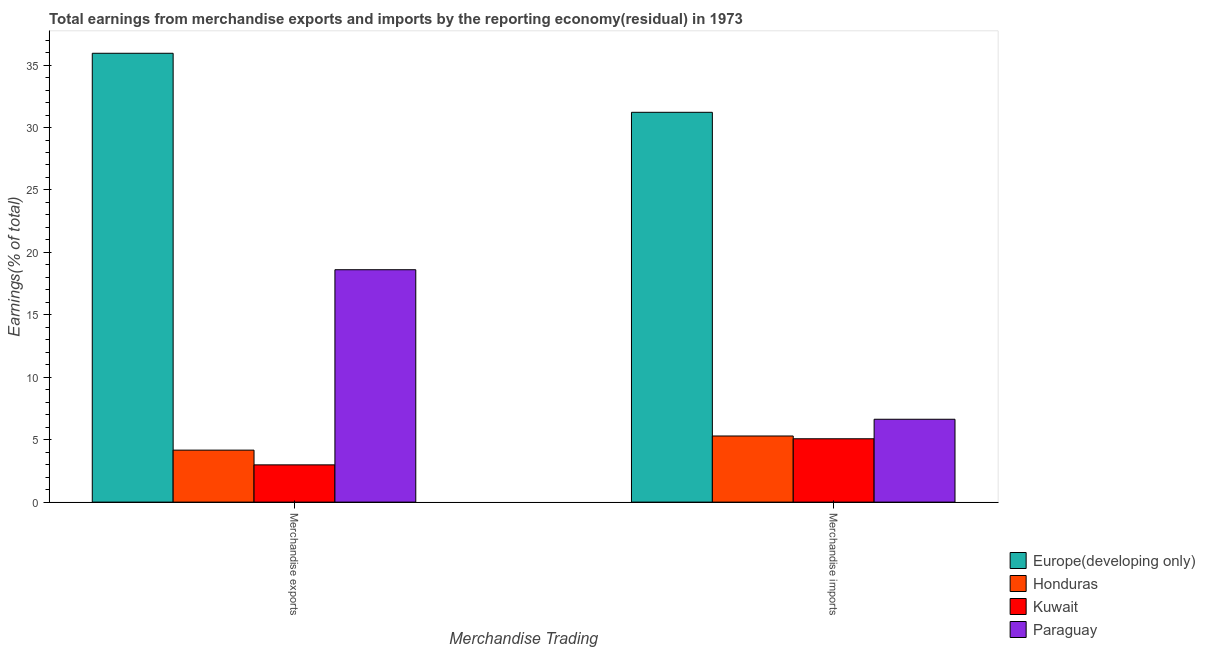Are the number of bars on each tick of the X-axis equal?
Offer a terse response. Yes. How many bars are there on the 2nd tick from the left?
Provide a short and direct response. 4. How many bars are there on the 1st tick from the right?
Your response must be concise. 4. What is the earnings from merchandise imports in Honduras?
Give a very brief answer. 5.3. Across all countries, what is the maximum earnings from merchandise imports?
Provide a short and direct response. 31.22. Across all countries, what is the minimum earnings from merchandise exports?
Make the answer very short. 2.98. In which country was the earnings from merchandise exports maximum?
Your answer should be compact. Europe(developing only). In which country was the earnings from merchandise imports minimum?
Your answer should be very brief. Kuwait. What is the total earnings from merchandise exports in the graph?
Your answer should be very brief. 61.71. What is the difference between the earnings from merchandise exports in Paraguay and that in Honduras?
Your response must be concise. 14.45. What is the difference between the earnings from merchandise exports in Paraguay and the earnings from merchandise imports in Honduras?
Your answer should be very brief. 13.32. What is the average earnings from merchandise exports per country?
Give a very brief answer. 15.43. What is the difference between the earnings from merchandise imports and earnings from merchandise exports in Europe(developing only)?
Offer a terse response. -4.73. What is the ratio of the earnings from merchandise imports in Kuwait to that in Honduras?
Your response must be concise. 0.96. In how many countries, is the earnings from merchandise imports greater than the average earnings from merchandise imports taken over all countries?
Offer a very short reply. 1. What does the 1st bar from the left in Merchandise imports represents?
Your answer should be very brief. Europe(developing only). What does the 1st bar from the right in Merchandise imports represents?
Make the answer very short. Paraguay. Are all the bars in the graph horizontal?
Make the answer very short. No. How many countries are there in the graph?
Your answer should be compact. 4. What is the difference between two consecutive major ticks on the Y-axis?
Your answer should be very brief. 5. Does the graph contain any zero values?
Keep it short and to the point. No. Does the graph contain grids?
Offer a very short reply. No. How are the legend labels stacked?
Provide a short and direct response. Vertical. What is the title of the graph?
Make the answer very short. Total earnings from merchandise exports and imports by the reporting economy(residual) in 1973. What is the label or title of the X-axis?
Provide a short and direct response. Merchandise Trading. What is the label or title of the Y-axis?
Ensure brevity in your answer.  Earnings(% of total). What is the Earnings(% of total) in Europe(developing only) in Merchandise exports?
Provide a succinct answer. 35.95. What is the Earnings(% of total) of Honduras in Merchandise exports?
Ensure brevity in your answer.  4.16. What is the Earnings(% of total) of Kuwait in Merchandise exports?
Offer a terse response. 2.98. What is the Earnings(% of total) of Paraguay in Merchandise exports?
Ensure brevity in your answer.  18.61. What is the Earnings(% of total) in Europe(developing only) in Merchandise imports?
Your answer should be very brief. 31.22. What is the Earnings(% of total) in Honduras in Merchandise imports?
Give a very brief answer. 5.3. What is the Earnings(% of total) in Kuwait in Merchandise imports?
Keep it short and to the point. 5.07. What is the Earnings(% of total) in Paraguay in Merchandise imports?
Keep it short and to the point. 6.64. Across all Merchandise Trading, what is the maximum Earnings(% of total) of Europe(developing only)?
Offer a very short reply. 35.95. Across all Merchandise Trading, what is the maximum Earnings(% of total) in Honduras?
Offer a terse response. 5.3. Across all Merchandise Trading, what is the maximum Earnings(% of total) in Kuwait?
Offer a very short reply. 5.07. Across all Merchandise Trading, what is the maximum Earnings(% of total) of Paraguay?
Make the answer very short. 18.61. Across all Merchandise Trading, what is the minimum Earnings(% of total) of Europe(developing only)?
Your response must be concise. 31.22. Across all Merchandise Trading, what is the minimum Earnings(% of total) of Honduras?
Keep it short and to the point. 4.16. Across all Merchandise Trading, what is the minimum Earnings(% of total) of Kuwait?
Your answer should be compact. 2.98. Across all Merchandise Trading, what is the minimum Earnings(% of total) in Paraguay?
Offer a terse response. 6.64. What is the total Earnings(% of total) in Europe(developing only) in the graph?
Offer a very short reply. 67.17. What is the total Earnings(% of total) in Honduras in the graph?
Provide a short and direct response. 9.46. What is the total Earnings(% of total) of Kuwait in the graph?
Provide a short and direct response. 8.06. What is the total Earnings(% of total) in Paraguay in the graph?
Your answer should be very brief. 25.25. What is the difference between the Earnings(% of total) of Europe(developing only) in Merchandise exports and that in Merchandise imports?
Give a very brief answer. 4.73. What is the difference between the Earnings(% of total) of Honduras in Merchandise exports and that in Merchandise imports?
Your response must be concise. -1.13. What is the difference between the Earnings(% of total) in Kuwait in Merchandise exports and that in Merchandise imports?
Offer a very short reply. -2.09. What is the difference between the Earnings(% of total) of Paraguay in Merchandise exports and that in Merchandise imports?
Provide a short and direct response. 11.98. What is the difference between the Earnings(% of total) in Europe(developing only) in Merchandise exports and the Earnings(% of total) in Honduras in Merchandise imports?
Keep it short and to the point. 30.65. What is the difference between the Earnings(% of total) in Europe(developing only) in Merchandise exports and the Earnings(% of total) in Kuwait in Merchandise imports?
Offer a terse response. 30.87. What is the difference between the Earnings(% of total) of Europe(developing only) in Merchandise exports and the Earnings(% of total) of Paraguay in Merchandise imports?
Offer a terse response. 29.31. What is the difference between the Earnings(% of total) in Honduras in Merchandise exports and the Earnings(% of total) in Kuwait in Merchandise imports?
Your answer should be compact. -0.91. What is the difference between the Earnings(% of total) in Honduras in Merchandise exports and the Earnings(% of total) in Paraguay in Merchandise imports?
Your answer should be compact. -2.47. What is the difference between the Earnings(% of total) in Kuwait in Merchandise exports and the Earnings(% of total) in Paraguay in Merchandise imports?
Your answer should be very brief. -3.65. What is the average Earnings(% of total) in Europe(developing only) per Merchandise Trading?
Offer a terse response. 33.58. What is the average Earnings(% of total) of Honduras per Merchandise Trading?
Your answer should be compact. 4.73. What is the average Earnings(% of total) of Kuwait per Merchandise Trading?
Offer a very short reply. 4.03. What is the average Earnings(% of total) of Paraguay per Merchandise Trading?
Offer a very short reply. 12.62. What is the difference between the Earnings(% of total) of Europe(developing only) and Earnings(% of total) of Honduras in Merchandise exports?
Your answer should be compact. 31.78. What is the difference between the Earnings(% of total) in Europe(developing only) and Earnings(% of total) in Kuwait in Merchandise exports?
Provide a short and direct response. 32.96. What is the difference between the Earnings(% of total) in Europe(developing only) and Earnings(% of total) in Paraguay in Merchandise exports?
Ensure brevity in your answer.  17.34. What is the difference between the Earnings(% of total) of Honduras and Earnings(% of total) of Kuwait in Merchandise exports?
Your answer should be compact. 1.18. What is the difference between the Earnings(% of total) of Honduras and Earnings(% of total) of Paraguay in Merchandise exports?
Ensure brevity in your answer.  -14.45. What is the difference between the Earnings(% of total) in Kuwait and Earnings(% of total) in Paraguay in Merchandise exports?
Your answer should be compact. -15.63. What is the difference between the Earnings(% of total) in Europe(developing only) and Earnings(% of total) in Honduras in Merchandise imports?
Make the answer very short. 25.92. What is the difference between the Earnings(% of total) of Europe(developing only) and Earnings(% of total) of Kuwait in Merchandise imports?
Your response must be concise. 26.15. What is the difference between the Earnings(% of total) in Europe(developing only) and Earnings(% of total) in Paraguay in Merchandise imports?
Your answer should be very brief. 24.58. What is the difference between the Earnings(% of total) in Honduras and Earnings(% of total) in Kuwait in Merchandise imports?
Offer a very short reply. 0.22. What is the difference between the Earnings(% of total) of Honduras and Earnings(% of total) of Paraguay in Merchandise imports?
Provide a short and direct response. -1.34. What is the difference between the Earnings(% of total) of Kuwait and Earnings(% of total) of Paraguay in Merchandise imports?
Keep it short and to the point. -1.56. What is the ratio of the Earnings(% of total) of Europe(developing only) in Merchandise exports to that in Merchandise imports?
Give a very brief answer. 1.15. What is the ratio of the Earnings(% of total) of Honduras in Merchandise exports to that in Merchandise imports?
Your response must be concise. 0.79. What is the ratio of the Earnings(% of total) in Kuwait in Merchandise exports to that in Merchandise imports?
Keep it short and to the point. 0.59. What is the ratio of the Earnings(% of total) in Paraguay in Merchandise exports to that in Merchandise imports?
Make the answer very short. 2.8. What is the difference between the highest and the second highest Earnings(% of total) in Europe(developing only)?
Your answer should be very brief. 4.73. What is the difference between the highest and the second highest Earnings(% of total) in Honduras?
Offer a terse response. 1.13. What is the difference between the highest and the second highest Earnings(% of total) in Kuwait?
Offer a very short reply. 2.09. What is the difference between the highest and the second highest Earnings(% of total) of Paraguay?
Your response must be concise. 11.98. What is the difference between the highest and the lowest Earnings(% of total) in Europe(developing only)?
Offer a terse response. 4.73. What is the difference between the highest and the lowest Earnings(% of total) of Honduras?
Offer a very short reply. 1.13. What is the difference between the highest and the lowest Earnings(% of total) in Kuwait?
Give a very brief answer. 2.09. What is the difference between the highest and the lowest Earnings(% of total) of Paraguay?
Keep it short and to the point. 11.98. 